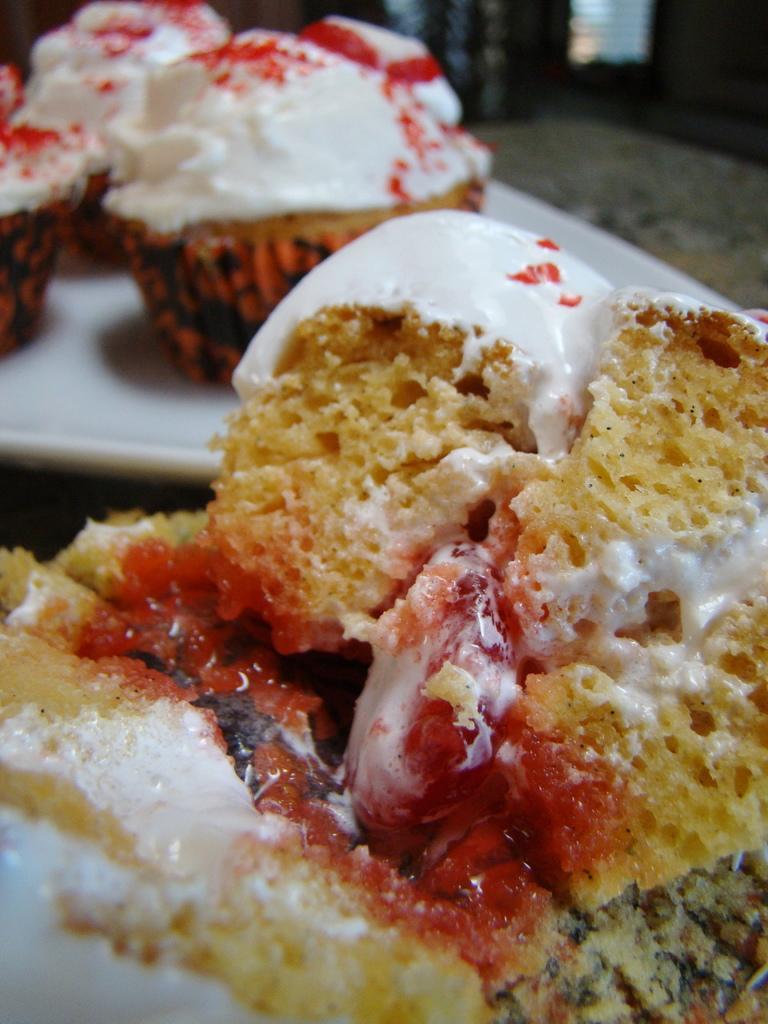Can you describe this image briefly? In this picture I can observe some food. The food is in yellow, white and red colors. In the background I can observe cupcakes placed in the white color plate. The plate is placed on the table. 